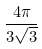<formula> <loc_0><loc_0><loc_500><loc_500>\frac { 4 \pi } { 3 \sqrt { 3 } }</formula> 